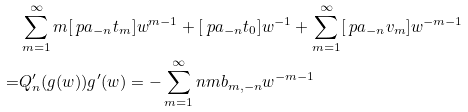<formula> <loc_0><loc_0><loc_500><loc_500>& \sum _ { m = 1 } ^ { \infty } m [ \ p a _ { - n } t _ { m } ] w ^ { m - 1 } + [ \ p a _ { - n } t _ { 0 } ] w ^ { - 1 } + \sum _ { m = 1 } ^ { \infty } [ \ p a _ { - n } v _ { m } ] w ^ { - m - 1 } \\ = & Q _ { n } ^ { \prime } ( g ( w ) ) g ^ { \prime } ( w ) = - \sum _ { m = 1 } ^ { \infty } n m b _ { m , - n } w ^ { - m - 1 }</formula> 